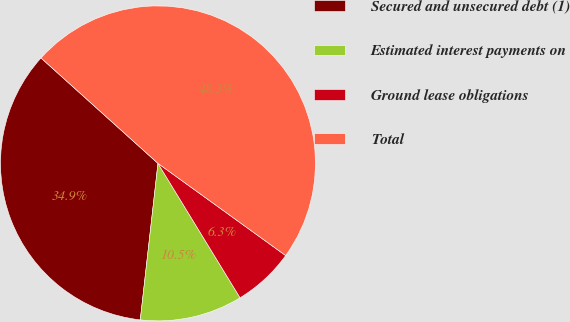Convert chart. <chart><loc_0><loc_0><loc_500><loc_500><pie_chart><fcel>Secured and unsecured debt (1)<fcel>Estimated interest payments on<fcel>Ground lease obligations<fcel>Total<nl><fcel>34.88%<fcel>10.52%<fcel>6.32%<fcel>48.28%<nl></chart> 